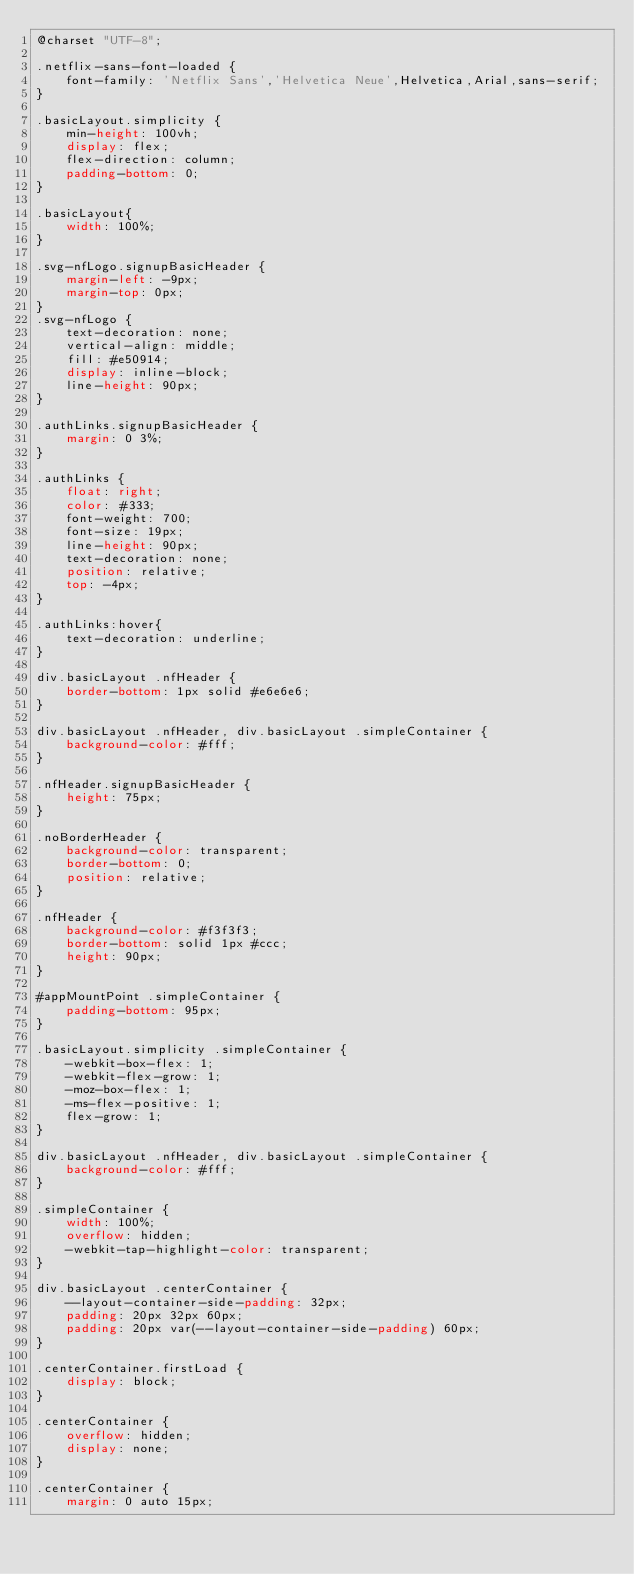Convert code to text. <code><loc_0><loc_0><loc_500><loc_500><_CSS_>@charset "UTF-8";

.netflix-sans-font-loaded {
    font-family: 'Netflix Sans','Helvetica Neue',Helvetica,Arial,sans-serif;
}

.basicLayout.simplicity {
    min-height: 100vh;   
    display: flex;    
    flex-direction: column;
    padding-bottom: 0;
}

.basicLayout{
	width: 100%;
} 

.svg-nfLogo.signupBasicHeader {
    margin-left: -9px;
    margin-top: 0px;
}
.svg-nfLogo {
    text-decoration: none;
    vertical-align: middle;
    fill: #e50914;
    display: inline-block;
    line-height: 90px;
}

.authLinks.signupBasicHeader {
    margin: 0 3%;
}

.authLinks {
    float: right;
    color: #333;
    font-weight: 700;
    font-size: 19px;
    line-height: 90px;
    text-decoration: none;
    position: relative;
    top: -4px;
}

.authLinks:hover{
	text-decoration: underline;	
}

div.basicLayout .nfHeader {
    border-bottom: 1px solid #e6e6e6;
}

div.basicLayout .nfHeader, div.basicLayout .simpleContainer {
    background-color: #fff;
}

.nfHeader.signupBasicHeader {
    height: 75px;
}

.noBorderHeader {
    background-color: transparent;
    border-bottom: 0;
    position: relative;
}

.nfHeader {
    background-color: #f3f3f3;
    border-bottom: solid 1px #ccc;
    height: 90px;
}

#appMountPoint .simpleContainer {
    padding-bottom: 95px;
}

.basicLayout.simplicity .simpleContainer {
    -webkit-box-flex: 1;
    -webkit-flex-grow: 1;
    -moz-box-flex: 1;
    -ms-flex-positive: 1;
    flex-grow: 1;
}

div.basicLayout .nfHeader, div.basicLayout .simpleContainer {
    background-color: #fff;
}

.simpleContainer {
    width: 100%;
    overflow: hidden;
    -webkit-tap-highlight-color: transparent;
}

div.basicLayout .centerContainer {
    --layout-container-side-padding: 32px;
    padding: 20px 32px 60px;
    padding: 20px var(--layout-container-side-padding) 60px;
}

.centerContainer.firstLoad {
    display: block;
}

.centerContainer {
    overflow: hidden;
    display: none;
}

.centerContainer {
    margin: 0 auto 15px;</code> 